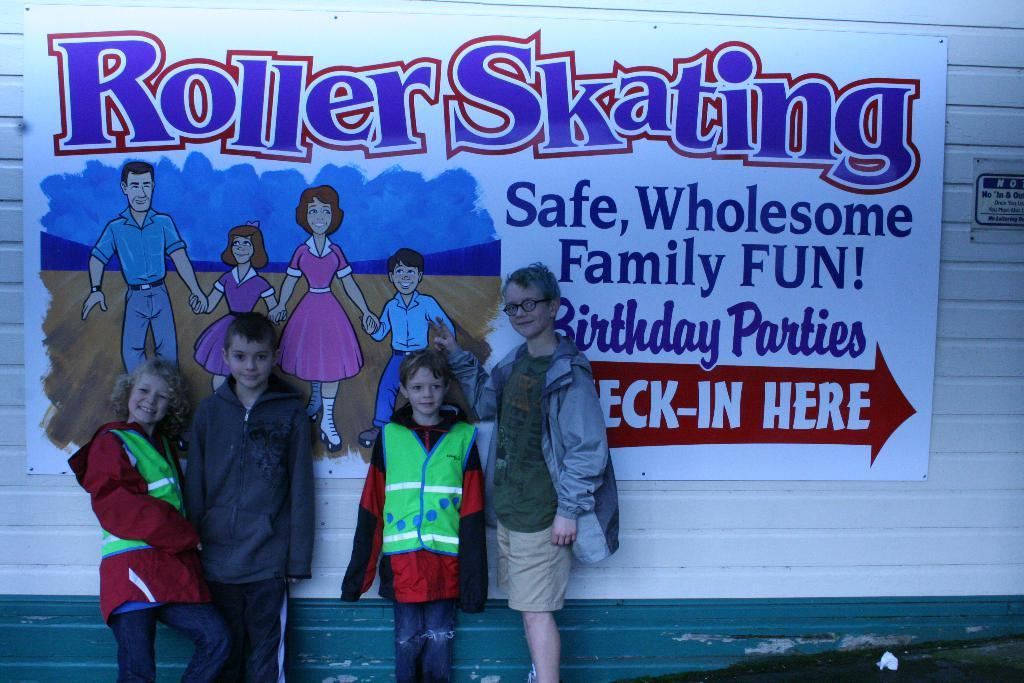<image>
Offer a succinct explanation of the picture presented. four kids in front of sign for roller skating and it has an arrow pointing to where you can check-in 